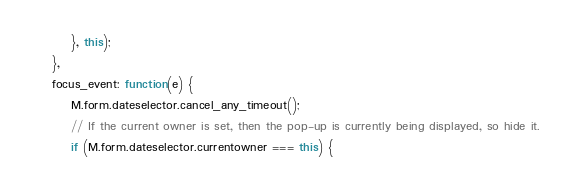Convert code to text. <code><loc_0><loc_0><loc_500><loc_500><_JavaScript_>        }, this);
    },
    focus_event: function(e) {
        M.form.dateselector.cancel_any_timeout();
        // If the current owner is set, then the pop-up is currently being displayed, so hide it.
        if (M.form.dateselector.currentowner === this) {</code> 